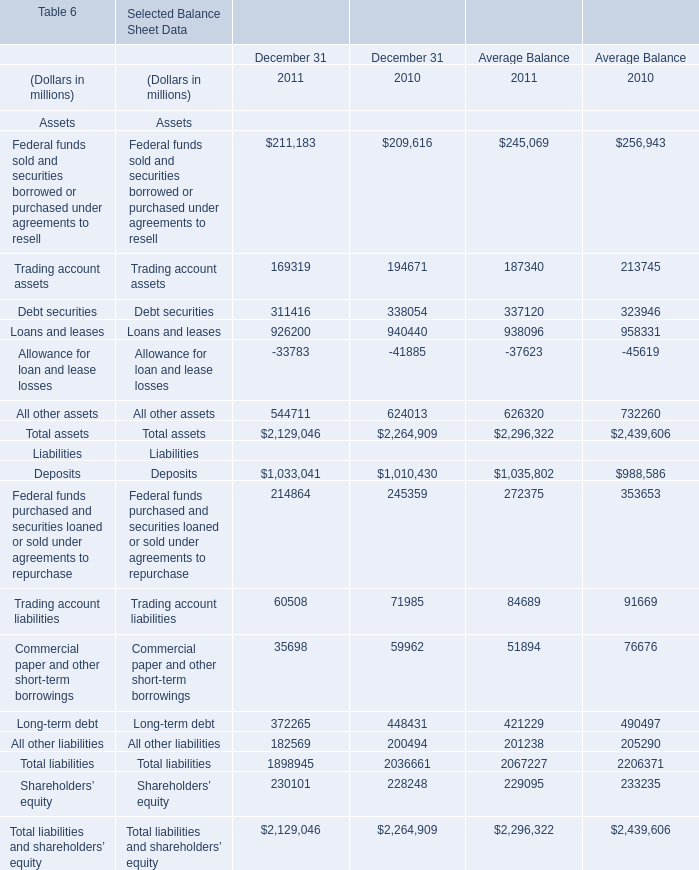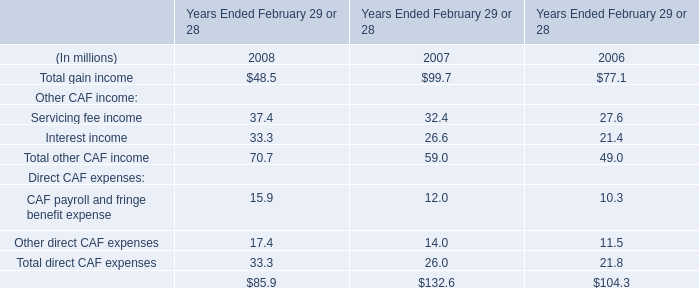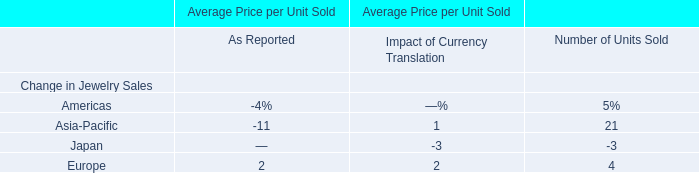What's the average of the Trading account assets in 2011 and 2010 for December 31 where Servicing fee income is positive? (in million) 
Computations: ((169319 + 194671) / 2)
Answer: 181995.0. 